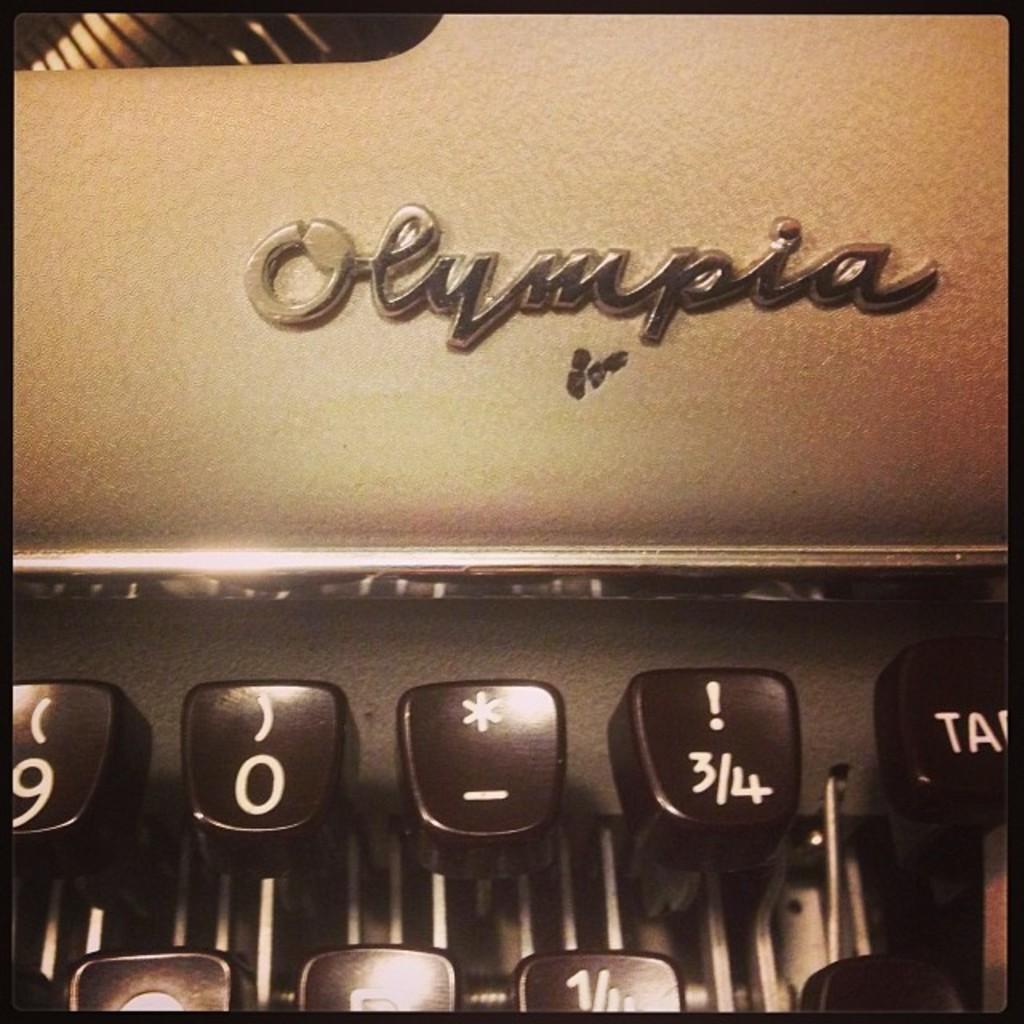What brand is this device?
Offer a terse response. Olympia. Is there a fraction on one of the keys?
Give a very brief answer. Yes. 